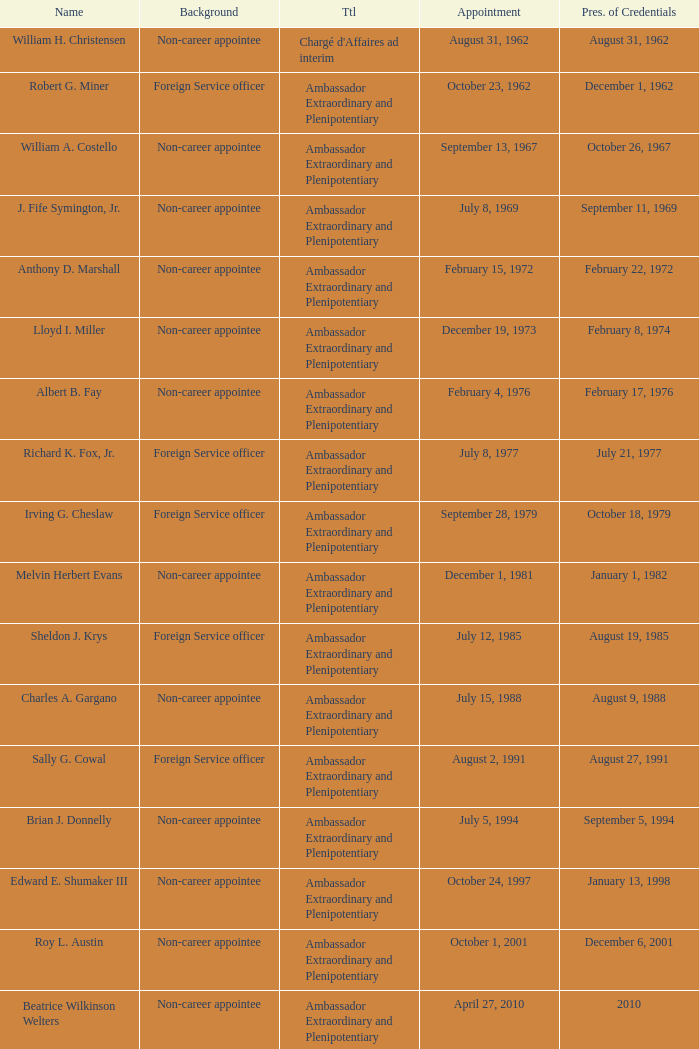Who was appointed on October 24, 1997? Edward E. Shumaker III. 